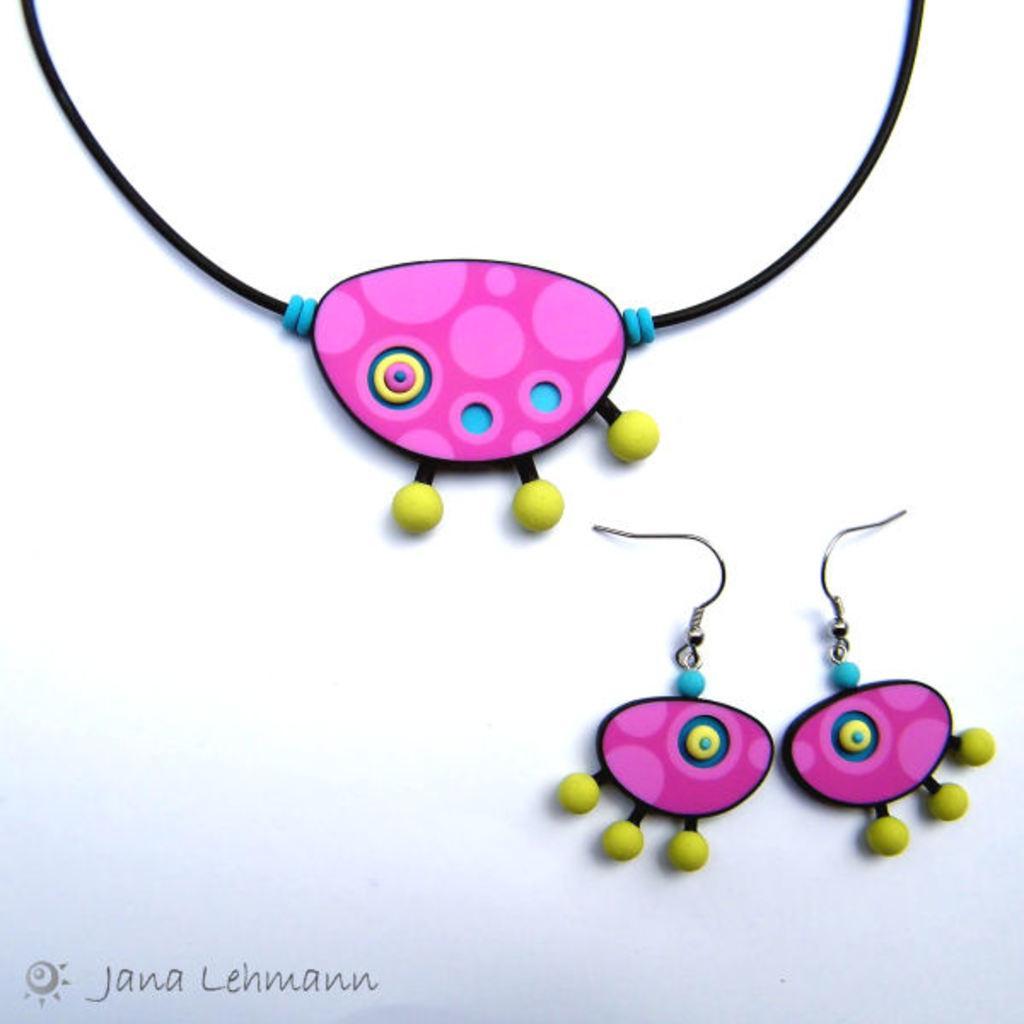In one or two sentences, can you explain what this image depicts? In this image I can see pair of earrings and a chain. There is a white background and in the bottom left corner of the image there is a watermark. 